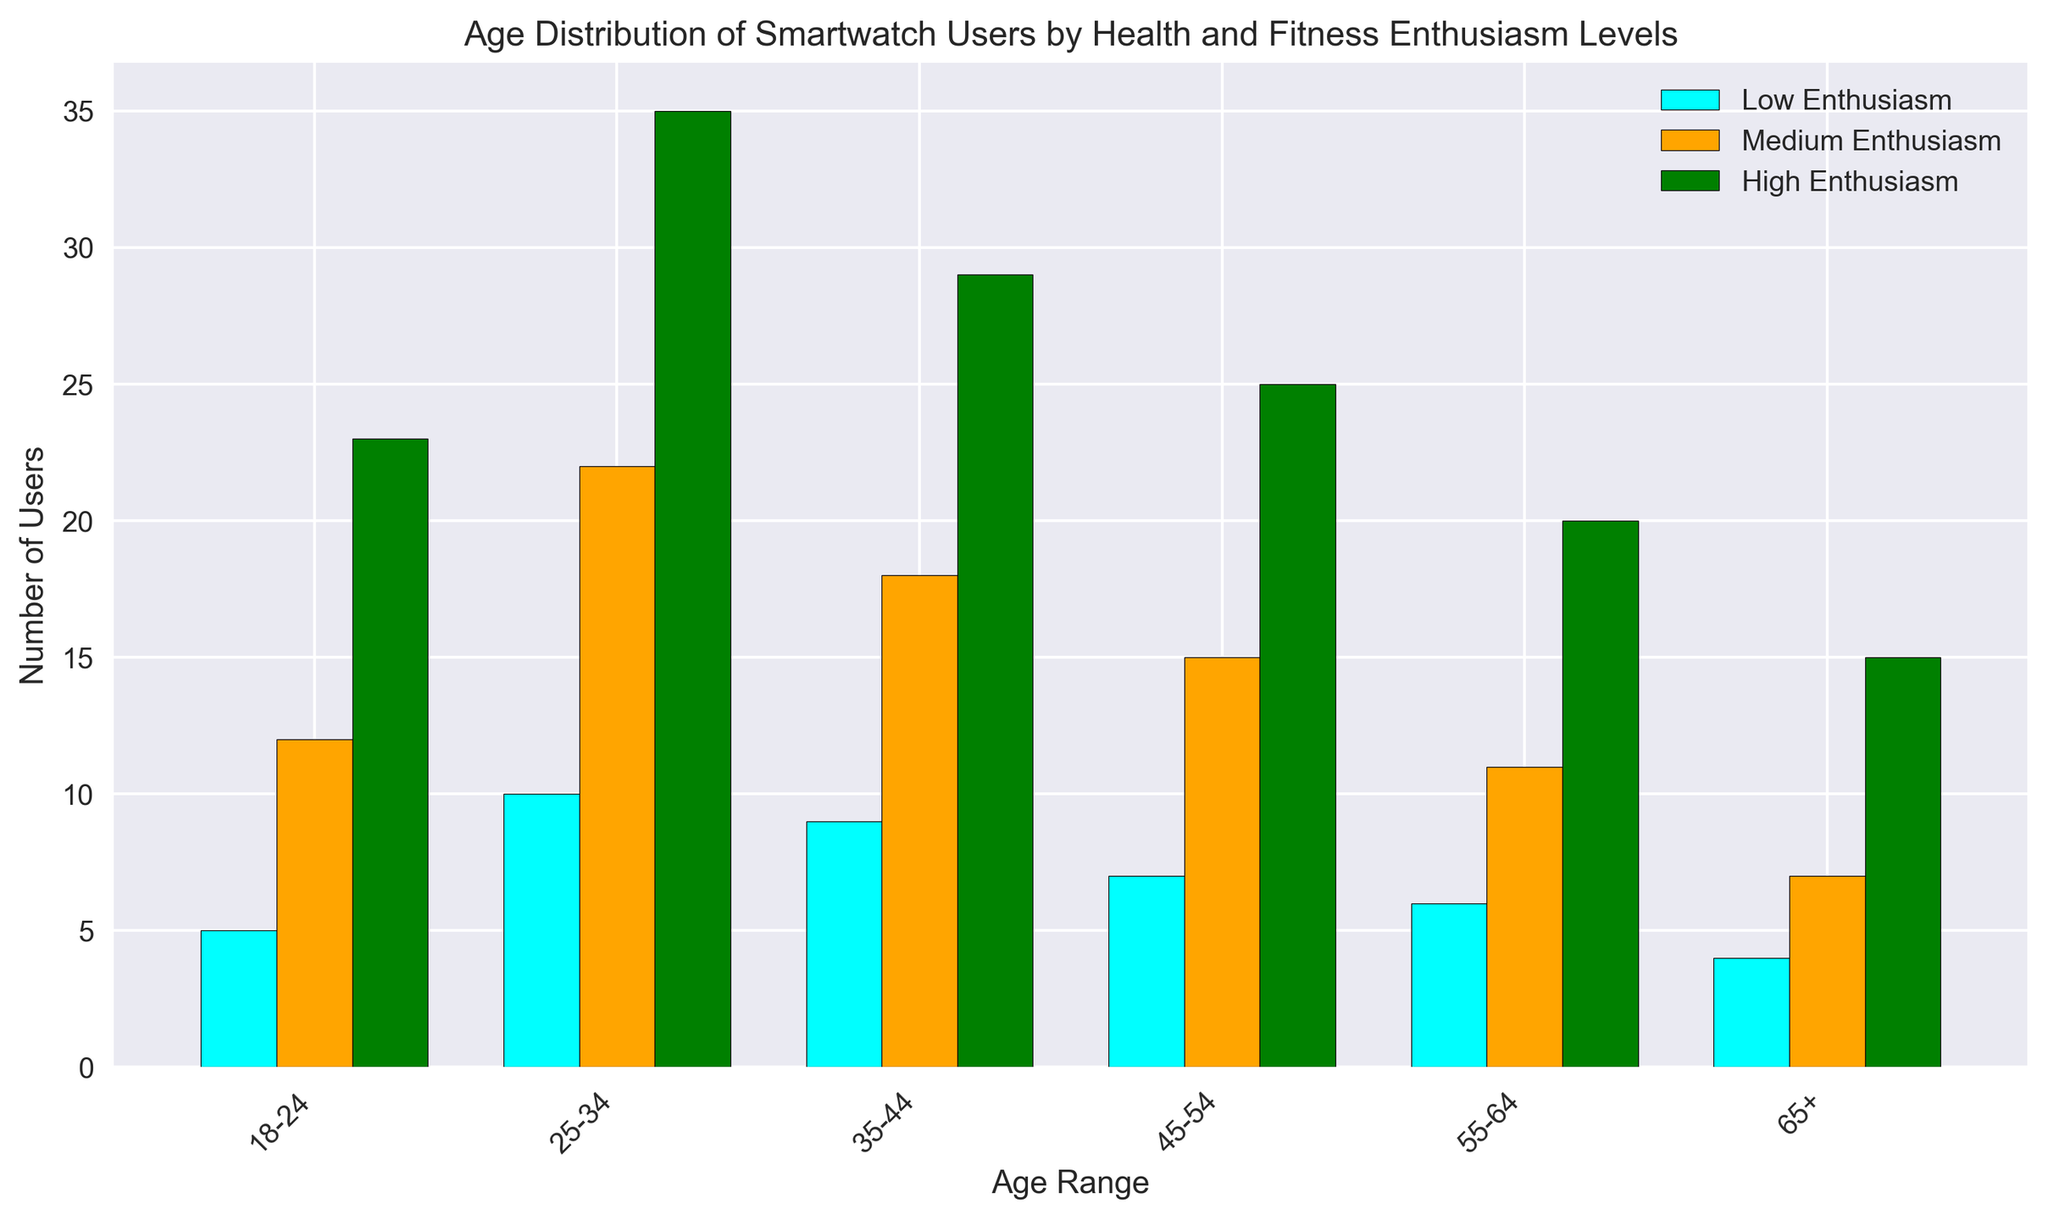What's the total number of smartwatch users in the age range 18-24? Sum the numbers of Low, Medium, and High Enthusiasm users in the 18-24 age range. (5 + 12 + 23) = 40
Answer: 40 Which age range has the highest number of High Enthusiasm users? Look for the tallest green bar, which represents High Enthusiasm, and check the corresponding age range label. The 25-34 age range has the highest green bar with 35 users.
Answer: 25-34 Compare the number of Medium Enthusiasm users in the 35-44 and 45-54 age ranges. Which is higher? Look at the heights of the orange bars for the 35-44 and 45-54 age ranges and compare them. The orange bar for 35-44 is at 18 and for 45-54 is at 15. Therefore, 35-44 has more Medium Enthusiasm users.
Answer: 35-44 What is the difference in the number of High Enthusiasm users between the 55-64 and 65+ age ranges? Subtract the number of High Enthusiasm users in the 65+ age range from the number in the 55-64 age range. (20 - 15) = 5
Answer: 5 How many total users have Medium Enthusiasm across all age ranges? Sum the numbers of Medium Enthusiasm users in each age range. (12 + 22 + 18 + 15 + 11 + 7) = 85
Answer: 85 Which age range shows the smallest number of Low Enthusiasm users? Identify the smallest cyan bar, which represents Low Enthusiasm, and check the corresponding age range. The 65+ age range has the smallest cyan bar with 4 users.
Answer: 65+ What is the average number of Low Enthusiasm users across all age ranges? Sum the numbers of Low Enthusiasm users and divide by the number of age ranges. (5 + 10 + 9 + 7 + 6 + 4)/6 = 41/6 ≈ 6.83
Answer: 6.83 For the age range 25-34, which enthusiasm level is most prevalent? Compare the heights of the cyan, orange, and green bars for the 25-34 age range. The green bar is the tallest at 35, indicating High Enthusiasm is most prevalent.
Answer: High Enthusiasm What is the ratio of High Enthusiasm users to Low Enthusiasm users in the 18-24 age range? Divide the number of High Enthusiasm users by the number of Low Enthusiasm users in the 18-24 age range. 23/5 = 4.6
Answer: 4.6 How does the number of Low Enthusiasm users in the 45-54 age range compare to the number of High Enthusiasm users in the 65+ age range? Compare the heights of the cyan bar for the 45-54 age range with the green bar for the 65+ age range. The values are 7 and 15, respectively, so 7 < 15.
Answer: Less 